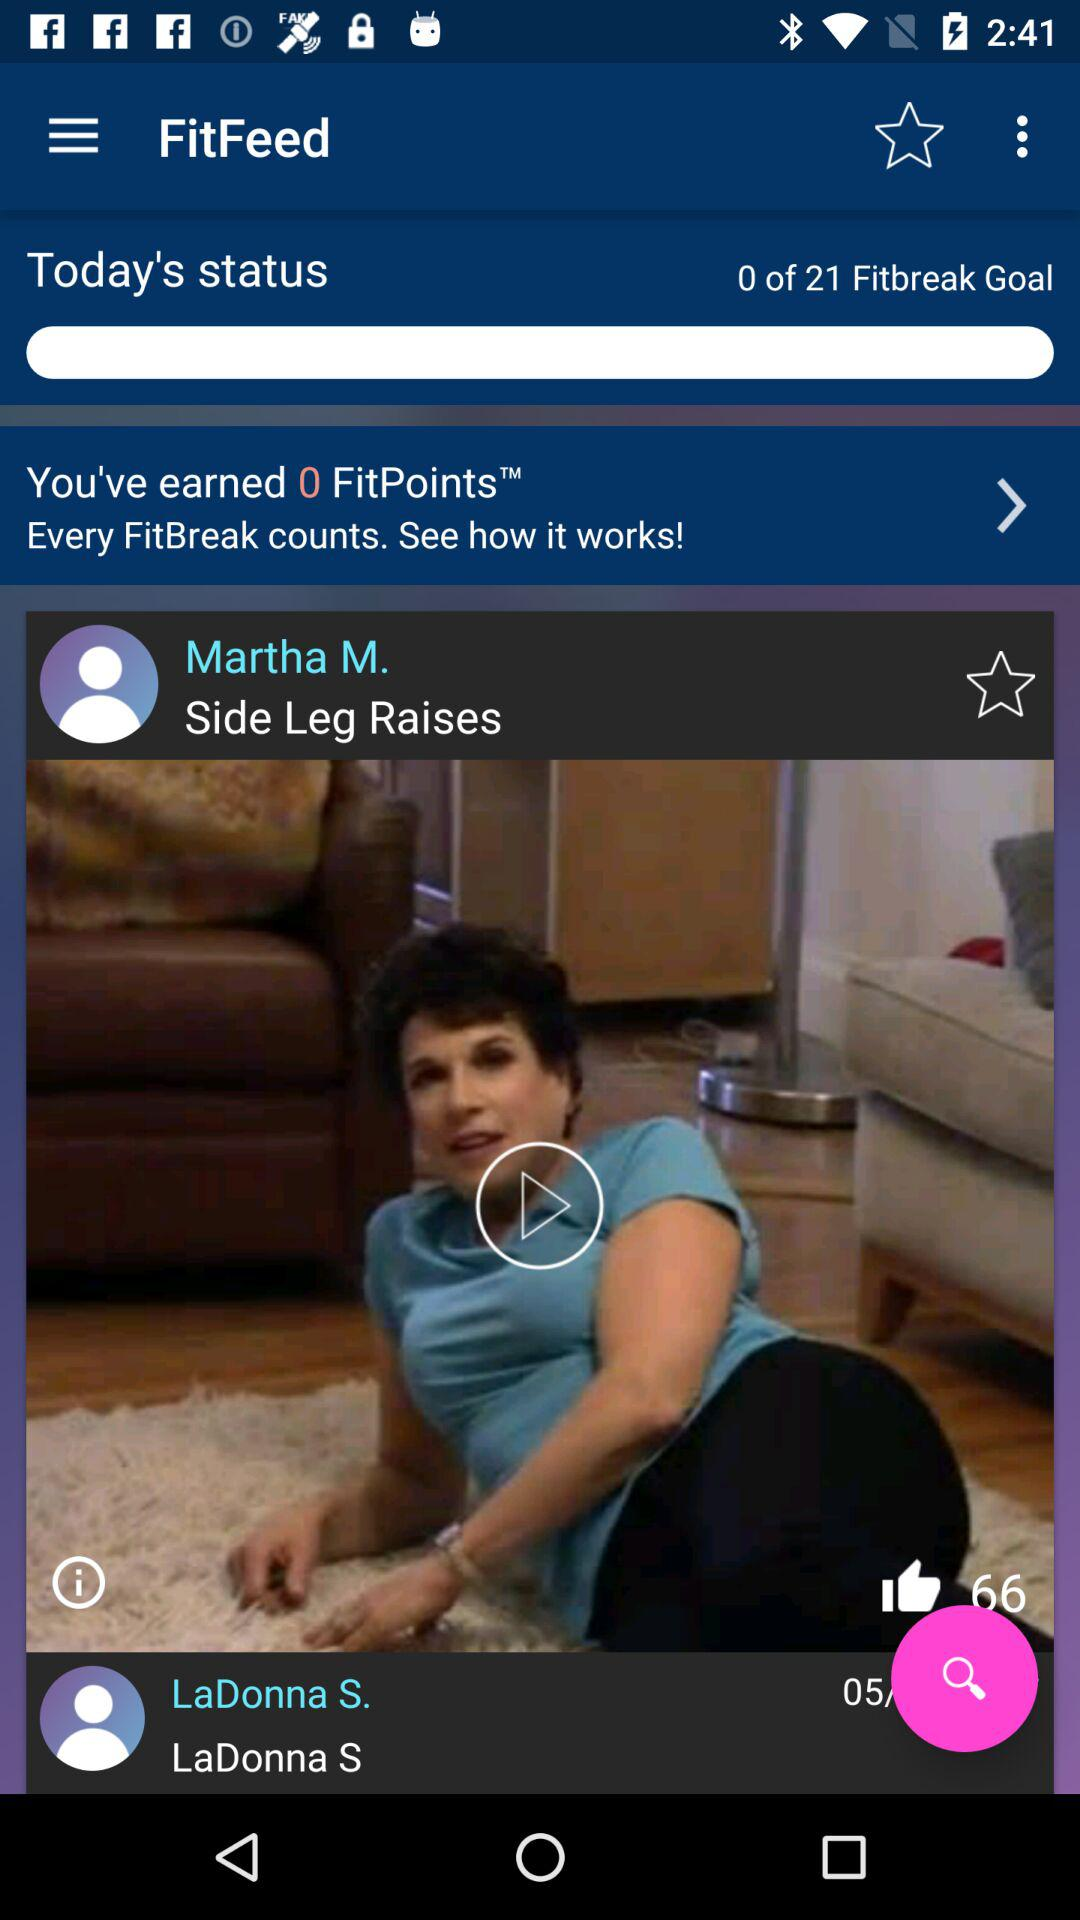What is the total number of "Fitbreak Goal"? The total number of "Fitbreak Goal" is 21. 